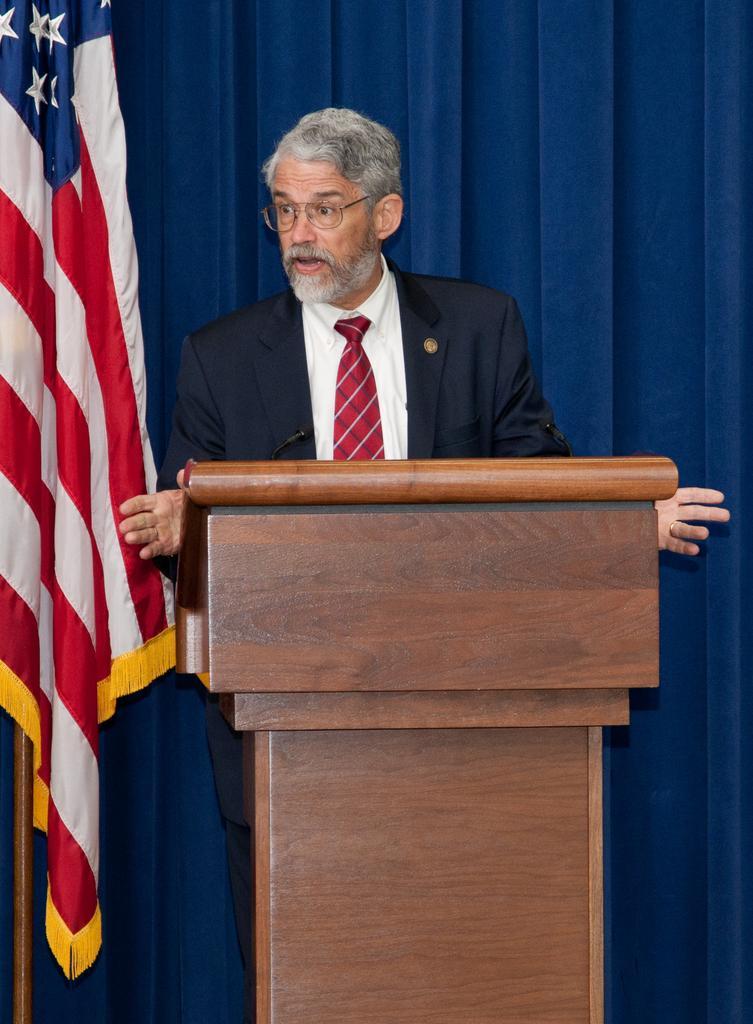In one or two sentences, can you explain what this image depicts? This image consists of a man wearing a black suit. He is standing in front of the podium. The podium is made up of wood. On the left, there is a flag. In the background, there is a curtain. 